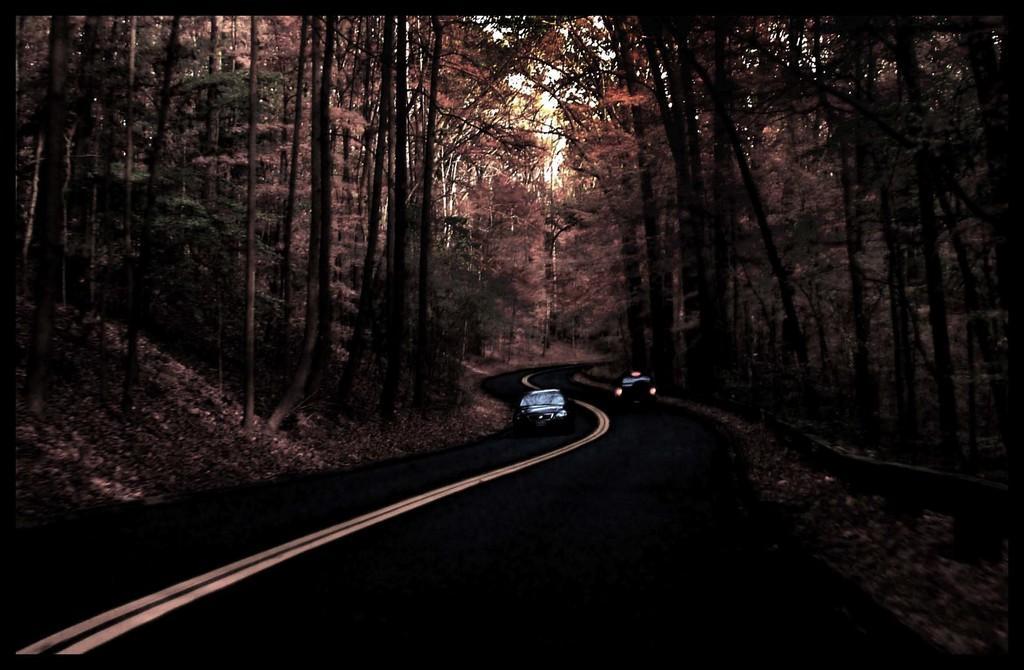Could you give a brief overview of what you see in this image? This is an edited image. In the center of the image we can see two vehicles. In the background of the image we can see the trees and dry leaves. At the bottom of the image we can see the road. 